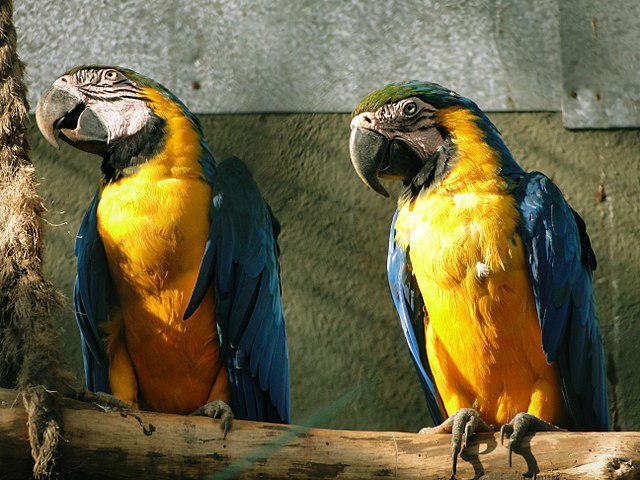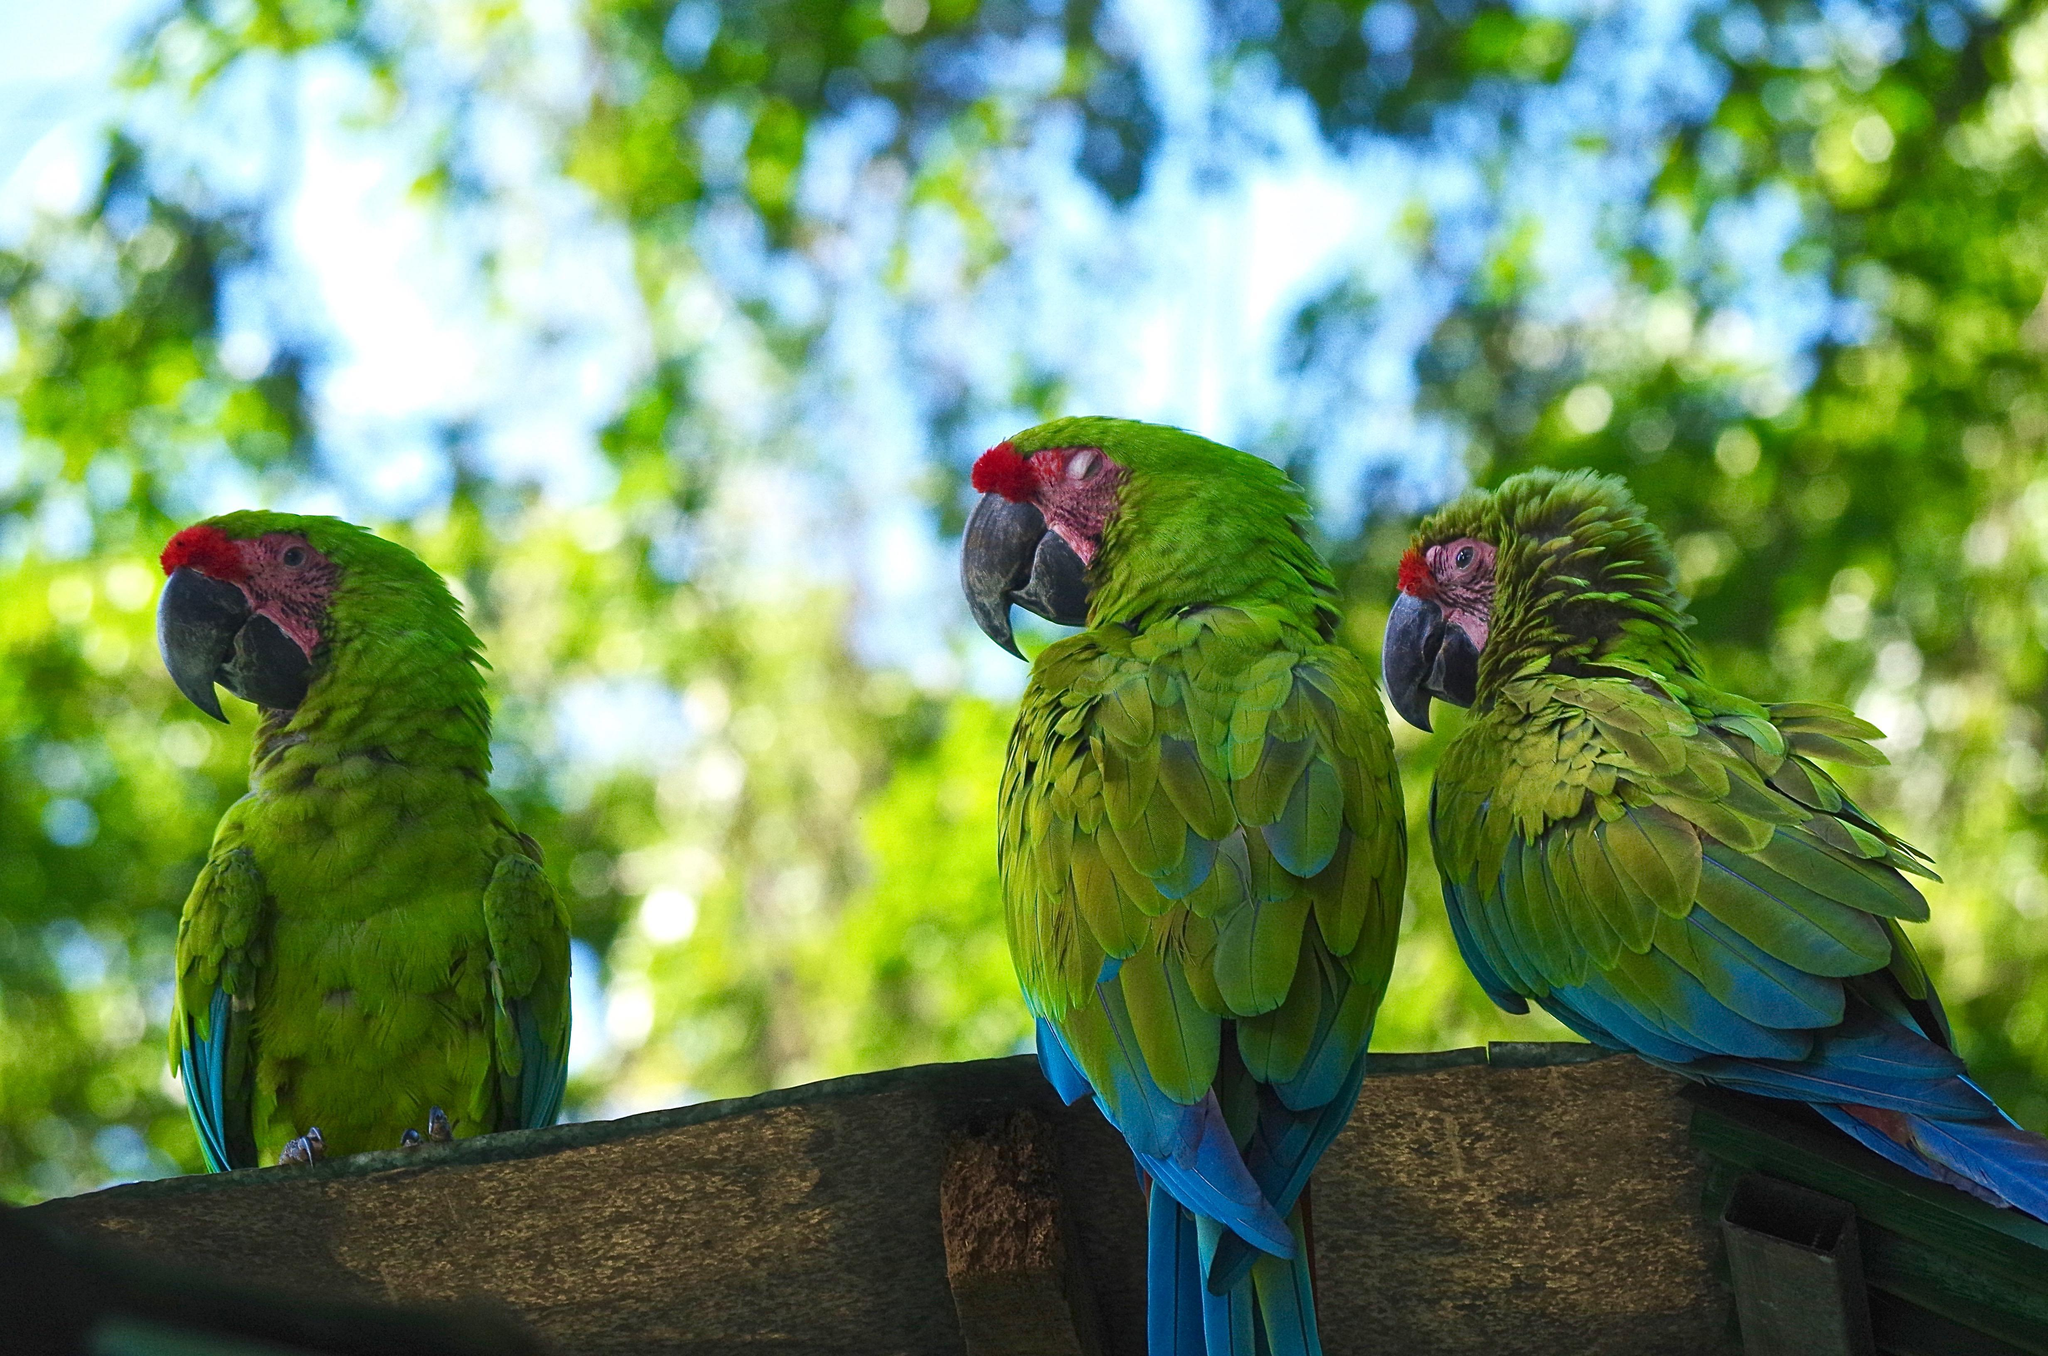The first image is the image on the left, the second image is the image on the right. For the images displayed, is the sentence "All birds are perched with wings folded, and at least one image shows multiple birds with the same coloring." factually correct? Answer yes or no. Yes. 